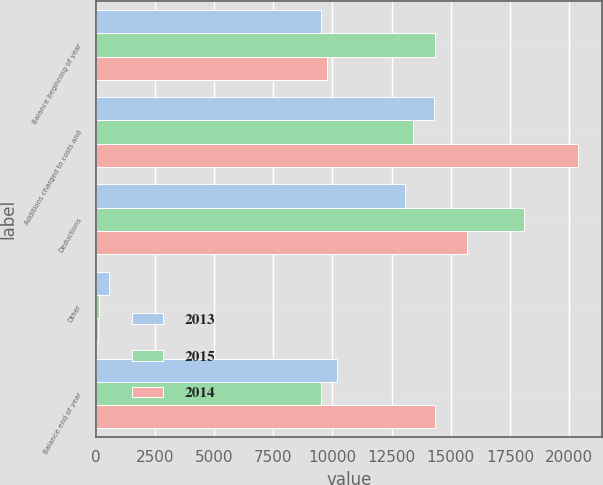Convert chart to OTSL. <chart><loc_0><loc_0><loc_500><loc_500><stacked_bar_chart><ecel><fcel>Balance beginning of year<fcel>Additions charged to costs and<fcel>Deductions<fcel>Other<fcel>Balance end of year<nl><fcel>2013<fcel>9537<fcel>14284<fcel>13059<fcel>579<fcel>10183<nl><fcel>2015<fcel>14336<fcel>13396<fcel>18078<fcel>117<fcel>9537<nl><fcel>2014<fcel>9755<fcel>20387<fcel>15697<fcel>109<fcel>14336<nl></chart> 